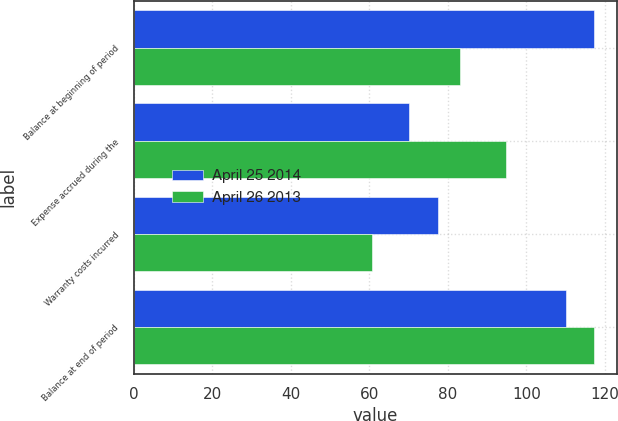Convert chart. <chart><loc_0><loc_0><loc_500><loc_500><stacked_bar_chart><ecel><fcel>Balance at beginning of period<fcel>Expense accrued during the<fcel>Warranty costs incurred<fcel>Balance at end of period<nl><fcel>April 25 2014<fcel>117.2<fcel>70.2<fcel>77.4<fcel>110<nl><fcel>April 26 2013<fcel>83.1<fcel>94.8<fcel>60.7<fcel>117.2<nl></chart> 